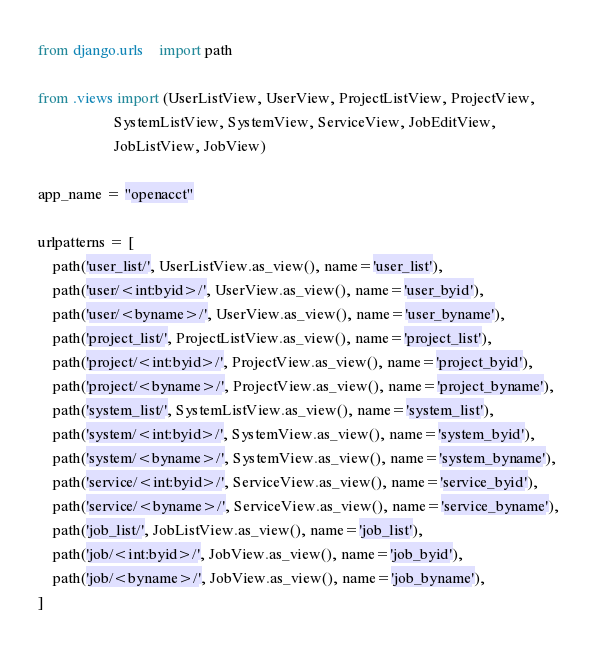Convert code to text. <code><loc_0><loc_0><loc_500><loc_500><_Python_>from django.urls    import path

from .views import (UserListView, UserView, ProjectListView, ProjectView, 
                    SystemListView, SystemView, ServiceView, JobEditView, 
                    JobListView, JobView)

app_name = "openacct"

urlpatterns = [
    path('user_list/', UserListView.as_view(), name='user_list'),
    path('user/<int:byid>/', UserView.as_view(), name='user_byid'),
    path('user/<byname>/', UserView.as_view(), name='user_byname'),
    path('project_list/', ProjectListView.as_view(), name='project_list'),
    path('project/<int:byid>/', ProjectView.as_view(), name='project_byid'),
    path('project/<byname>/', ProjectView.as_view(), name='project_byname'),
    path('system_list/', SystemListView.as_view(), name='system_list'),
    path('system/<int:byid>/', SystemView.as_view(), name='system_byid'),
    path('system/<byname>/', SystemView.as_view(), name='system_byname'),
    path('service/<int:byid>/', ServiceView.as_view(), name='service_byid'),
    path('service/<byname>/', ServiceView.as_view(), name='service_byname'),
    path('job_list/', JobListView.as_view(), name='job_list'),
    path('job/<int:byid>/', JobView.as_view(), name='job_byid'),
    path('job/<byname>/', JobView.as_view(), name='job_byname'),
]
</code> 